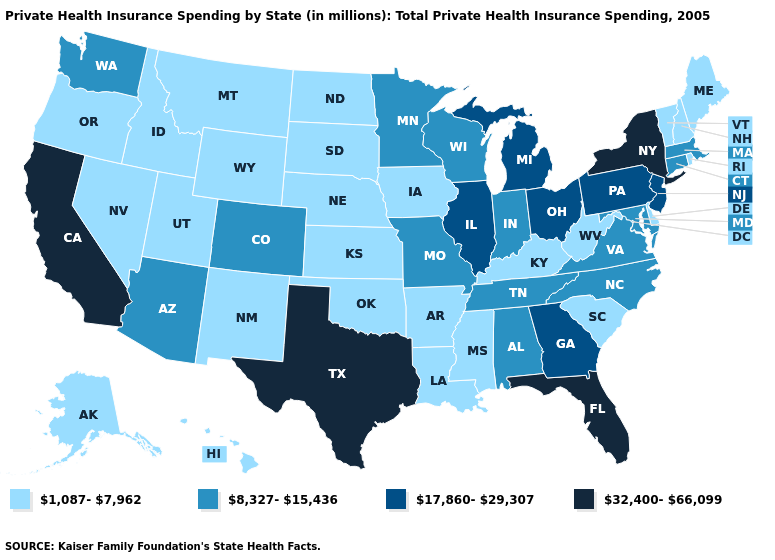Which states have the lowest value in the USA?
Give a very brief answer. Alaska, Arkansas, Delaware, Hawaii, Idaho, Iowa, Kansas, Kentucky, Louisiana, Maine, Mississippi, Montana, Nebraska, Nevada, New Hampshire, New Mexico, North Dakota, Oklahoma, Oregon, Rhode Island, South Carolina, South Dakota, Utah, Vermont, West Virginia, Wyoming. What is the value of Texas?
Short answer required. 32,400-66,099. What is the lowest value in the MidWest?
Write a very short answer. 1,087-7,962. Name the states that have a value in the range 32,400-66,099?
Keep it brief. California, Florida, New York, Texas. What is the highest value in the USA?
Answer briefly. 32,400-66,099. What is the value of Montana?
Quick response, please. 1,087-7,962. Name the states that have a value in the range 1,087-7,962?
Short answer required. Alaska, Arkansas, Delaware, Hawaii, Idaho, Iowa, Kansas, Kentucky, Louisiana, Maine, Mississippi, Montana, Nebraska, Nevada, New Hampshire, New Mexico, North Dakota, Oklahoma, Oregon, Rhode Island, South Carolina, South Dakota, Utah, Vermont, West Virginia, Wyoming. Name the states that have a value in the range 8,327-15,436?
Give a very brief answer. Alabama, Arizona, Colorado, Connecticut, Indiana, Maryland, Massachusetts, Minnesota, Missouri, North Carolina, Tennessee, Virginia, Washington, Wisconsin. Does the map have missing data?
Give a very brief answer. No. How many symbols are there in the legend?
Answer briefly. 4. Among the states that border Nevada , does Idaho have the highest value?
Answer briefly. No. Does the first symbol in the legend represent the smallest category?
Keep it brief. Yes. Among the states that border Iowa , which have the highest value?
Keep it brief. Illinois. Among the states that border Tennessee , which have the highest value?
Give a very brief answer. Georgia. Name the states that have a value in the range 8,327-15,436?
Concise answer only. Alabama, Arizona, Colorado, Connecticut, Indiana, Maryland, Massachusetts, Minnesota, Missouri, North Carolina, Tennessee, Virginia, Washington, Wisconsin. 